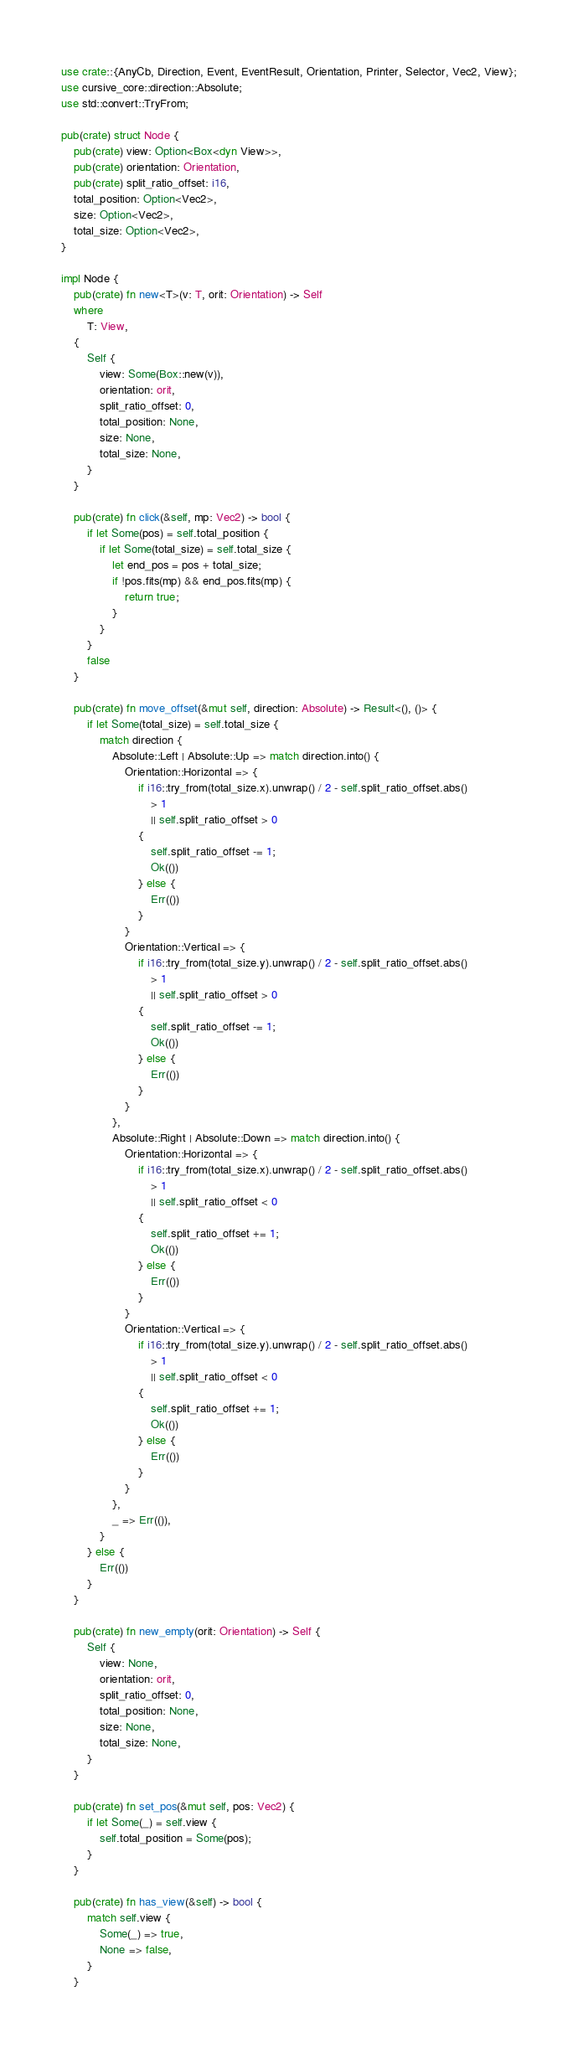<code> <loc_0><loc_0><loc_500><loc_500><_Rust_>use crate::{AnyCb, Direction, Event, EventResult, Orientation, Printer, Selector, Vec2, View};
use cursive_core::direction::Absolute;
use std::convert::TryFrom;

pub(crate) struct Node {
    pub(crate) view: Option<Box<dyn View>>,
    pub(crate) orientation: Orientation,
    pub(crate) split_ratio_offset: i16,
    total_position: Option<Vec2>,
    size: Option<Vec2>,
    total_size: Option<Vec2>,
}

impl Node {
    pub(crate) fn new<T>(v: T, orit: Orientation) -> Self
    where
        T: View,
    {
        Self {
            view: Some(Box::new(v)),
            orientation: orit,
            split_ratio_offset: 0,
            total_position: None,
            size: None,
            total_size: None,
        }
    }

    pub(crate) fn click(&self, mp: Vec2) -> bool {
        if let Some(pos) = self.total_position {
            if let Some(total_size) = self.total_size {
                let end_pos = pos + total_size;
                if !pos.fits(mp) && end_pos.fits(mp) {
                    return true;
                }
            }
        }
        false
    }

    pub(crate) fn move_offset(&mut self, direction: Absolute) -> Result<(), ()> {
        if let Some(total_size) = self.total_size {
            match direction {
                Absolute::Left | Absolute::Up => match direction.into() {
                    Orientation::Horizontal => {
                        if i16::try_from(total_size.x).unwrap() / 2 - self.split_ratio_offset.abs()
                            > 1
                            || self.split_ratio_offset > 0
                        {
                            self.split_ratio_offset -= 1;
                            Ok(())
                        } else {
                            Err(())
                        }
                    }
                    Orientation::Vertical => {
                        if i16::try_from(total_size.y).unwrap() / 2 - self.split_ratio_offset.abs()
                            > 1
                            || self.split_ratio_offset > 0
                        {
                            self.split_ratio_offset -= 1;
                            Ok(())
                        } else {
                            Err(())
                        }
                    }
                },
                Absolute::Right | Absolute::Down => match direction.into() {
                    Orientation::Horizontal => {
                        if i16::try_from(total_size.x).unwrap() / 2 - self.split_ratio_offset.abs()
                            > 1
                            || self.split_ratio_offset < 0
                        {
                            self.split_ratio_offset += 1;
                            Ok(())
                        } else {
                            Err(())
                        }
                    }
                    Orientation::Vertical => {
                        if i16::try_from(total_size.y).unwrap() / 2 - self.split_ratio_offset.abs()
                            > 1
                            || self.split_ratio_offset < 0
                        {
                            self.split_ratio_offset += 1;
                            Ok(())
                        } else {
                            Err(())
                        }
                    }
                },
                _ => Err(()),
            }
        } else {
            Err(())
        }
    }

    pub(crate) fn new_empty(orit: Orientation) -> Self {
        Self {
            view: None,
            orientation: orit,
            split_ratio_offset: 0,
            total_position: None,
            size: None,
            total_size: None,
        }
    }

    pub(crate) fn set_pos(&mut self, pos: Vec2) {
        if let Some(_) = self.view {
            self.total_position = Some(pos);
        }
    }

    pub(crate) fn has_view(&self) -> bool {
        match self.view {
            Some(_) => true,
            None => false,
        }
    }
</code> 